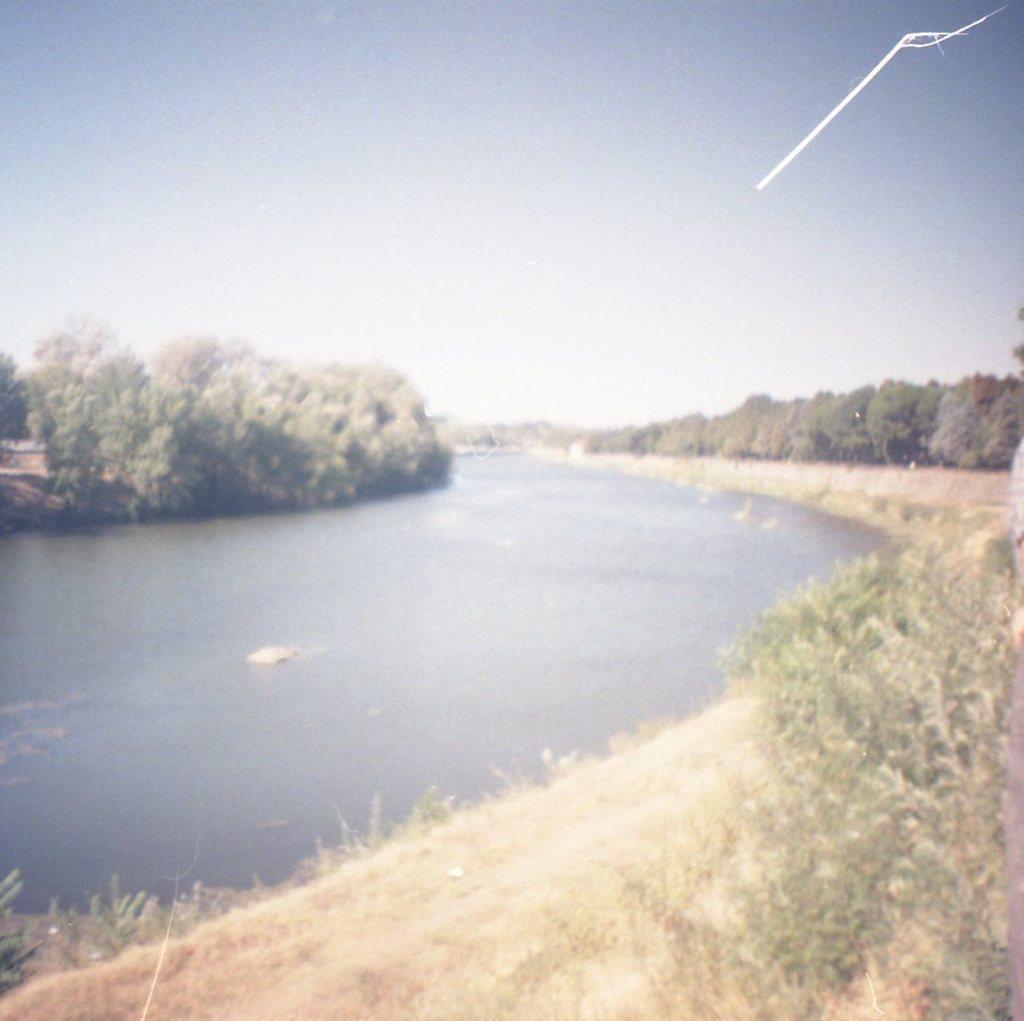How would you summarize this image in a sentence or two? In this picture I can see there is a river and there are few rocks and there are few plants and trees at right and there are a few more trees at left and the sky is clear. 